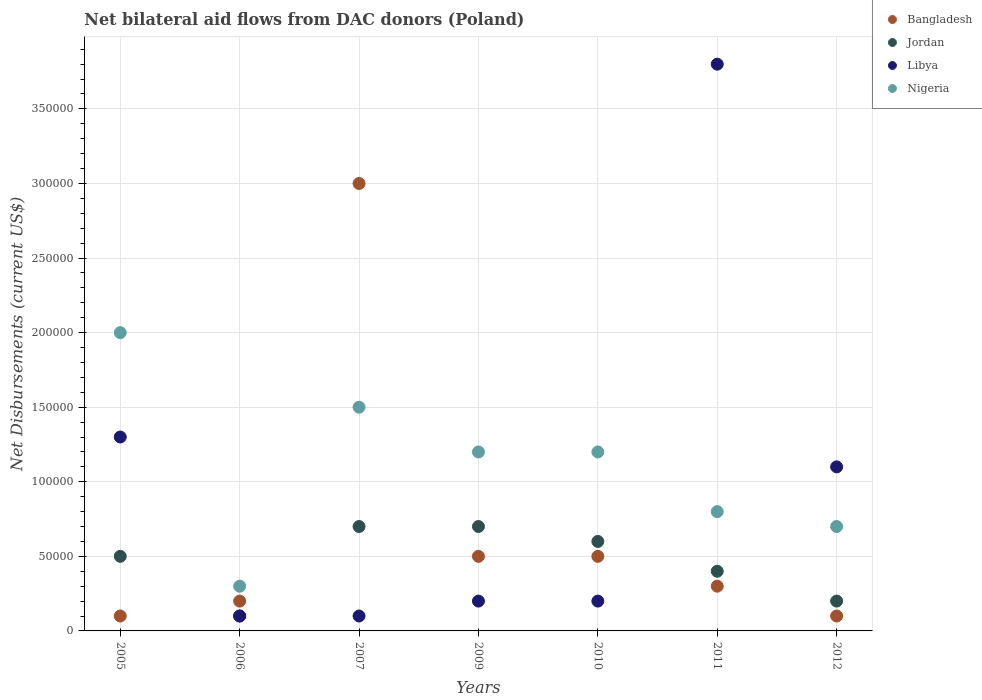How many different coloured dotlines are there?
Provide a short and direct response. 4. What is the net bilateral aid flows in Jordan in 2009?
Provide a succinct answer. 7.00e+04. Across all years, what is the maximum net bilateral aid flows in Bangladesh?
Your answer should be compact. 3.00e+05. Across all years, what is the minimum net bilateral aid flows in Bangladesh?
Make the answer very short. 10000. What is the total net bilateral aid flows in Jordan in the graph?
Ensure brevity in your answer.  3.20e+05. What is the difference between the net bilateral aid flows in Nigeria in 2007 and that in 2010?
Offer a terse response. 3.00e+04. What is the difference between the net bilateral aid flows in Nigeria in 2007 and the net bilateral aid flows in Jordan in 2010?
Ensure brevity in your answer.  9.00e+04. What is the average net bilateral aid flows in Jordan per year?
Give a very brief answer. 4.57e+04. In the year 2009, what is the difference between the net bilateral aid flows in Libya and net bilateral aid flows in Jordan?
Provide a succinct answer. -5.00e+04. Is the net bilateral aid flows in Nigeria in 2007 less than that in 2012?
Give a very brief answer. No. What is the difference between the highest and the second highest net bilateral aid flows in Nigeria?
Offer a terse response. 5.00e+04. What is the difference between the highest and the lowest net bilateral aid flows in Nigeria?
Give a very brief answer. 1.70e+05. In how many years, is the net bilateral aid flows in Jordan greater than the average net bilateral aid flows in Jordan taken over all years?
Keep it short and to the point. 4. Is the net bilateral aid flows in Jordan strictly less than the net bilateral aid flows in Libya over the years?
Make the answer very short. No. How many dotlines are there?
Offer a very short reply. 4. How many years are there in the graph?
Your answer should be compact. 7. What is the difference between two consecutive major ticks on the Y-axis?
Offer a very short reply. 5.00e+04. Does the graph contain any zero values?
Offer a terse response. No. Where does the legend appear in the graph?
Your answer should be compact. Top right. How many legend labels are there?
Keep it short and to the point. 4. What is the title of the graph?
Provide a short and direct response. Net bilateral aid flows from DAC donors (Poland). Does "Spain" appear as one of the legend labels in the graph?
Give a very brief answer. No. What is the label or title of the Y-axis?
Make the answer very short. Net Disbursements (current US$). What is the Net Disbursements (current US$) in Bangladesh in 2005?
Offer a terse response. 10000. What is the Net Disbursements (current US$) in Jordan in 2005?
Keep it short and to the point. 5.00e+04. What is the Net Disbursements (current US$) of Bangladesh in 2006?
Your response must be concise. 2.00e+04. What is the Net Disbursements (current US$) of Jordan in 2006?
Provide a short and direct response. 10000. What is the Net Disbursements (current US$) in Nigeria in 2006?
Keep it short and to the point. 3.00e+04. What is the Net Disbursements (current US$) in Bangladesh in 2007?
Offer a terse response. 3.00e+05. What is the Net Disbursements (current US$) in Jordan in 2007?
Your answer should be compact. 7.00e+04. What is the Net Disbursements (current US$) of Libya in 2007?
Make the answer very short. 10000. What is the Net Disbursements (current US$) of Nigeria in 2007?
Offer a very short reply. 1.50e+05. What is the Net Disbursements (current US$) in Bangladesh in 2009?
Keep it short and to the point. 5.00e+04. What is the Net Disbursements (current US$) in Libya in 2009?
Provide a short and direct response. 2.00e+04. What is the Net Disbursements (current US$) in Bangladesh in 2010?
Provide a succinct answer. 5.00e+04. What is the Net Disbursements (current US$) in Jordan in 2010?
Ensure brevity in your answer.  6.00e+04. What is the Net Disbursements (current US$) in Nigeria in 2010?
Provide a short and direct response. 1.20e+05. What is the Net Disbursements (current US$) in Bangladesh in 2011?
Provide a short and direct response. 3.00e+04. What is the Net Disbursements (current US$) of Libya in 2011?
Make the answer very short. 3.80e+05. What is the Net Disbursements (current US$) of Nigeria in 2011?
Provide a succinct answer. 8.00e+04. What is the Net Disbursements (current US$) in Bangladesh in 2012?
Your answer should be very brief. 10000. What is the Net Disbursements (current US$) in Nigeria in 2012?
Your answer should be very brief. 7.00e+04. Across all years, what is the maximum Net Disbursements (current US$) in Bangladesh?
Give a very brief answer. 3.00e+05. Across all years, what is the maximum Net Disbursements (current US$) of Libya?
Your answer should be compact. 3.80e+05. Across all years, what is the maximum Net Disbursements (current US$) of Nigeria?
Your answer should be very brief. 2.00e+05. Across all years, what is the minimum Net Disbursements (current US$) in Bangladesh?
Provide a succinct answer. 10000. Across all years, what is the minimum Net Disbursements (current US$) in Jordan?
Your answer should be very brief. 10000. Across all years, what is the minimum Net Disbursements (current US$) of Libya?
Ensure brevity in your answer.  10000. Across all years, what is the minimum Net Disbursements (current US$) in Nigeria?
Provide a succinct answer. 3.00e+04. What is the total Net Disbursements (current US$) in Bangladesh in the graph?
Provide a succinct answer. 4.70e+05. What is the total Net Disbursements (current US$) of Jordan in the graph?
Your response must be concise. 3.20e+05. What is the total Net Disbursements (current US$) in Libya in the graph?
Your answer should be compact. 6.80e+05. What is the total Net Disbursements (current US$) of Nigeria in the graph?
Provide a short and direct response. 7.70e+05. What is the difference between the Net Disbursements (current US$) in Bangladesh in 2005 and that in 2006?
Offer a very short reply. -10000. What is the difference between the Net Disbursements (current US$) in Jordan in 2005 and that in 2006?
Make the answer very short. 4.00e+04. What is the difference between the Net Disbursements (current US$) in Jordan in 2005 and that in 2007?
Provide a succinct answer. -2.00e+04. What is the difference between the Net Disbursements (current US$) in Jordan in 2005 and that in 2009?
Your response must be concise. -2.00e+04. What is the difference between the Net Disbursements (current US$) of Libya in 2005 and that in 2009?
Your answer should be compact. 1.10e+05. What is the difference between the Net Disbursements (current US$) of Nigeria in 2005 and that in 2009?
Offer a very short reply. 8.00e+04. What is the difference between the Net Disbursements (current US$) in Jordan in 2005 and that in 2010?
Keep it short and to the point. -10000. What is the difference between the Net Disbursements (current US$) in Libya in 2005 and that in 2010?
Provide a short and direct response. 1.10e+05. What is the difference between the Net Disbursements (current US$) in Nigeria in 2005 and that in 2010?
Your answer should be compact. 8.00e+04. What is the difference between the Net Disbursements (current US$) of Jordan in 2005 and that in 2011?
Your answer should be very brief. 10000. What is the difference between the Net Disbursements (current US$) in Libya in 2005 and that in 2011?
Your answer should be very brief. -2.50e+05. What is the difference between the Net Disbursements (current US$) in Bangladesh in 2005 and that in 2012?
Provide a succinct answer. 0. What is the difference between the Net Disbursements (current US$) of Libya in 2005 and that in 2012?
Offer a very short reply. 2.00e+04. What is the difference between the Net Disbursements (current US$) in Nigeria in 2005 and that in 2012?
Offer a very short reply. 1.30e+05. What is the difference between the Net Disbursements (current US$) in Bangladesh in 2006 and that in 2007?
Make the answer very short. -2.80e+05. What is the difference between the Net Disbursements (current US$) in Nigeria in 2006 and that in 2007?
Offer a terse response. -1.20e+05. What is the difference between the Net Disbursements (current US$) in Bangladesh in 2006 and that in 2009?
Offer a terse response. -3.00e+04. What is the difference between the Net Disbursements (current US$) in Libya in 2006 and that in 2009?
Offer a terse response. -10000. What is the difference between the Net Disbursements (current US$) of Bangladesh in 2006 and that in 2010?
Provide a short and direct response. -3.00e+04. What is the difference between the Net Disbursements (current US$) in Jordan in 2006 and that in 2010?
Ensure brevity in your answer.  -5.00e+04. What is the difference between the Net Disbursements (current US$) in Libya in 2006 and that in 2010?
Keep it short and to the point. -10000. What is the difference between the Net Disbursements (current US$) in Nigeria in 2006 and that in 2010?
Make the answer very short. -9.00e+04. What is the difference between the Net Disbursements (current US$) of Bangladesh in 2006 and that in 2011?
Your response must be concise. -10000. What is the difference between the Net Disbursements (current US$) in Jordan in 2006 and that in 2011?
Offer a terse response. -3.00e+04. What is the difference between the Net Disbursements (current US$) in Libya in 2006 and that in 2011?
Your response must be concise. -3.70e+05. What is the difference between the Net Disbursements (current US$) in Bangladesh in 2006 and that in 2012?
Make the answer very short. 10000. What is the difference between the Net Disbursements (current US$) of Jordan in 2006 and that in 2012?
Keep it short and to the point. -10000. What is the difference between the Net Disbursements (current US$) of Nigeria in 2006 and that in 2012?
Offer a terse response. -4.00e+04. What is the difference between the Net Disbursements (current US$) of Jordan in 2007 and that in 2009?
Give a very brief answer. 0. What is the difference between the Net Disbursements (current US$) of Libya in 2007 and that in 2009?
Give a very brief answer. -10000. What is the difference between the Net Disbursements (current US$) in Nigeria in 2007 and that in 2009?
Provide a succinct answer. 3.00e+04. What is the difference between the Net Disbursements (current US$) in Bangladesh in 2007 and that in 2010?
Provide a short and direct response. 2.50e+05. What is the difference between the Net Disbursements (current US$) in Libya in 2007 and that in 2010?
Keep it short and to the point. -10000. What is the difference between the Net Disbursements (current US$) in Jordan in 2007 and that in 2011?
Ensure brevity in your answer.  3.00e+04. What is the difference between the Net Disbursements (current US$) in Libya in 2007 and that in 2011?
Provide a short and direct response. -3.70e+05. What is the difference between the Net Disbursements (current US$) of Jordan in 2007 and that in 2012?
Your answer should be compact. 5.00e+04. What is the difference between the Net Disbursements (current US$) of Libya in 2007 and that in 2012?
Provide a short and direct response. -1.00e+05. What is the difference between the Net Disbursements (current US$) of Nigeria in 2007 and that in 2012?
Provide a short and direct response. 8.00e+04. What is the difference between the Net Disbursements (current US$) in Bangladesh in 2009 and that in 2010?
Offer a terse response. 0. What is the difference between the Net Disbursements (current US$) in Libya in 2009 and that in 2011?
Your response must be concise. -3.60e+05. What is the difference between the Net Disbursements (current US$) of Jordan in 2009 and that in 2012?
Offer a very short reply. 5.00e+04. What is the difference between the Net Disbursements (current US$) of Libya in 2009 and that in 2012?
Keep it short and to the point. -9.00e+04. What is the difference between the Net Disbursements (current US$) of Nigeria in 2009 and that in 2012?
Your answer should be very brief. 5.00e+04. What is the difference between the Net Disbursements (current US$) of Jordan in 2010 and that in 2011?
Your answer should be compact. 2.00e+04. What is the difference between the Net Disbursements (current US$) of Libya in 2010 and that in 2011?
Offer a terse response. -3.60e+05. What is the difference between the Net Disbursements (current US$) in Libya in 2010 and that in 2012?
Give a very brief answer. -9.00e+04. What is the difference between the Net Disbursements (current US$) in Nigeria in 2010 and that in 2012?
Ensure brevity in your answer.  5.00e+04. What is the difference between the Net Disbursements (current US$) of Bangladesh in 2011 and that in 2012?
Make the answer very short. 2.00e+04. What is the difference between the Net Disbursements (current US$) in Jordan in 2011 and that in 2012?
Keep it short and to the point. 2.00e+04. What is the difference between the Net Disbursements (current US$) in Libya in 2011 and that in 2012?
Your answer should be very brief. 2.70e+05. What is the difference between the Net Disbursements (current US$) in Bangladesh in 2005 and the Net Disbursements (current US$) in Jordan in 2006?
Keep it short and to the point. 0. What is the difference between the Net Disbursements (current US$) of Libya in 2005 and the Net Disbursements (current US$) of Nigeria in 2006?
Your answer should be very brief. 1.00e+05. What is the difference between the Net Disbursements (current US$) of Bangladesh in 2005 and the Net Disbursements (current US$) of Nigeria in 2007?
Offer a very short reply. -1.40e+05. What is the difference between the Net Disbursements (current US$) in Jordan in 2005 and the Net Disbursements (current US$) in Libya in 2007?
Offer a terse response. 4.00e+04. What is the difference between the Net Disbursements (current US$) in Jordan in 2005 and the Net Disbursements (current US$) in Nigeria in 2007?
Make the answer very short. -1.00e+05. What is the difference between the Net Disbursements (current US$) in Bangladesh in 2005 and the Net Disbursements (current US$) in Jordan in 2009?
Your answer should be very brief. -6.00e+04. What is the difference between the Net Disbursements (current US$) of Bangladesh in 2005 and the Net Disbursements (current US$) of Libya in 2009?
Offer a terse response. -10000. What is the difference between the Net Disbursements (current US$) in Jordan in 2005 and the Net Disbursements (current US$) in Nigeria in 2009?
Provide a short and direct response. -7.00e+04. What is the difference between the Net Disbursements (current US$) in Libya in 2005 and the Net Disbursements (current US$) in Nigeria in 2009?
Your response must be concise. 10000. What is the difference between the Net Disbursements (current US$) in Bangladesh in 2005 and the Net Disbursements (current US$) in Jordan in 2010?
Offer a terse response. -5.00e+04. What is the difference between the Net Disbursements (current US$) in Libya in 2005 and the Net Disbursements (current US$) in Nigeria in 2010?
Offer a terse response. 10000. What is the difference between the Net Disbursements (current US$) of Bangladesh in 2005 and the Net Disbursements (current US$) of Libya in 2011?
Your answer should be compact. -3.70e+05. What is the difference between the Net Disbursements (current US$) in Jordan in 2005 and the Net Disbursements (current US$) in Libya in 2011?
Ensure brevity in your answer.  -3.30e+05. What is the difference between the Net Disbursements (current US$) in Jordan in 2005 and the Net Disbursements (current US$) in Nigeria in 2011?
Your response must be concise. -3.00e+04. What is the difference between the Net Disbursements (current US$) in Libya in 2005 and the Net Disbursements (current US$) in Nigeria in 2011?
Your answer should be very brief. 5.00e+04. What is the difference between the Net Disbursements (current US$) of Jordan in 2005 and the Net Disbursements (current US$) of Nigeria in 2012?
Your answer should be compact. -2.00e+04. What is the difference between the Net Disbursements (current US$) in Libya in 2005 and the Net Disbursements (current US$) in Nigeria in 2012?
Provide a succinct answer. 6.00e+04. What is the difference between the Net Disbursements (current US$) in Bangladesh in 2006 and the Net Disbursements (current US$) in Jordan in 2007?
Keep it short and to the point. -5.00e+04. What is the difference between the Net Disbursements (current US$) of Bangladesh in 2006 and the Net Disbursements (current US$) of Libya in 2007?
Offer a terse response. 10000. What is the difference between the Net Disbursements (current US$) in Jordan in 2006 and the Net Disbursements (current US$) in Libya in 2007?
Your answer should be compact. 0. What is the difference between the Net Disbursements (current US$) in Jordan in 2006 and the Net Disbursements (current US$) in Nigeria in 2007?
Offer a terse response. -1.40e+05. What is the difference between the Net Disbursements (current US$) of Bangladesh in 2006 and the Net Disbursements (current US$) of Jordan in 2009?
Make the answer very short. -5.00e+04. What is the difference between the Net Disbursements (current US$) of Jordan in 2006 and the Net Disbursements (current US$) of Libya in 2009?
Give a very brief answer. -10000. What is the difference between the Net Disbursements (current US$) of Jordan in 2006 and the Net Disbursements (current US$) of Nigeria in 2009?
Offer a terse response. -1.10e+05. What is the difference between the Net Disbursements (current US$) in Libya in 2006 and the Net Disbursements (current US$) in Nigeria in 2009?
Offer a very short reply. -1.10e+05. What is the difference between the Net Disbursements (current US$) of Bangladesh in 2006 and the Net Disbursements (current US$) of Libya in 2010?
Keep it short and to the point. 0. What is the difference between the Net Disbursements (current US$) in Bangladesh in 2006 and the Net Disbursements (current US$) in Nigeria in 2010?
Provide a succinct answer. -1.00e+05. What is the difference between the Net Disbursements (current US$) of Jordan in 2006 and the Net Disbursements (current US$) of Libya in 2010?
Keep it short and to the point. -10000. What is the difference between the Net Disbursements (current US$) in Jordan in 2006 and the Net Disbursements (current US$) in Nigeria in 2010?
Offer a very short reply. -1.10e+05. What is the difference between the Net Disbursements (current US$) in Libya in 2006 and the Net Disbursements (current US$) in Nigeria in 2010?
Offer a terse response. -1.10e+05. What is the difference between the Net Disbursements (current US$) in Bangladesh in 2006 and the Net Disbursements (current US$) in Jordan in 2011?
Keep it short and to the point. -2.00e+04. What is the difference between the Net Disbursements (current US$) of Bangladesh in 2006 and the Net Disbursements (current US$) of Libya in 2011?
Offer a very short reply. -3.60e+05. What is the difference between the Net Disbursements (current US$) in Bangladesh in 2006 and the Net Disbursements (current US$) in Nigeria in 2011?
Your answer should be very brief. -6.00e+04. What is the difference between the Net Disbursements (current US$) in Jordan in 2006 and the Net Disbursements (current US$) in Libya in 2011?
Give a very brief answer. -3.70e+05. What is the difference between the Net Disbursements (current US$) in Jordan in 2006 and the Net Disbursements (current US$) in Nigeria in 2011?
Your response must be concise. -7.00e+04. What is the difference between the Net Disbursements (current US$) of Libya in 2006 and the Net Disbursements (current US$) of Nigeria in 2011?
Your answer should be compact. -7.00e+04. What is the difference between the Net Disbursements (current US$) of Bangladesh in 2006 and the Net Disbursements (current US$) of Jordan in 2012?
Provide a short and direct response. 0. What is the difference between the Net Disbursements (current US$) of Jordan in 2006 and the Net Disbursements (current US$) of Libya in 2012?
Your answer should be very brief. -1.00e+05. What is the difference between the Net Disbursements (current US$) of Bangladesh in 2007 and the Net Disbursements (current US$) of Libya in 2009?
Offer a very short reply. 2.80e+05. What is the difference between the Net Disbursements (current US$) in Jordan in 2007 and the Net Disbursements (current US$) in Nigeria in 2009?
Make the answer very short. -5.00e+04. What is the difference between the Net Disbursements (current US$) of Libya in 2007 and the Net Disbursements (current US$) of Nigeria in 2009?
Make the answer very short. -1.10e+05. What is the difference between the Net Disbursements (current US$) of Jordan in 2007 and the Net Disbursements (current US$) of Libya in 2010?
Make the answer very short. 5.00e+04. What is the difference between the Net Disbursements (current US$) in Libya in 2007 and the Net Disbursements (current US$) in Nigeria in 2010?
Offer a very short reply. -1.10e+05. What is the difference between the Net Disbursements (current US$) in Bangladesh in 2007 and the Net Disbursements (current US$) in Jordan in 2011?
Make the answer very short. 2.60e+05. What is the difference between the Net Disbursements (current US$) in Bangladesh in 2007 and the Net Disbursements (current US$) in Nigeria in 2011?
Make the answer very short. 2.20e+05. What is the difference between the Net Disbursements (current US$) of Jordan in 2007 and the Net Disbursements (current US$) of Libya in 2011?
Ensure brevity in your answer.  -3.10e+05. What is the difference between the Net Disbursements (current US$) in Bangladesh in 2007 and the Net Disbursements (current US$) in Jordan in 2012?
Your answer should be very brief. 2.80e+05. What is the difference between the Net Disbursements (current US$) of Jordan in 2007 and the Net Disbursements (current US$) of Nigeria in 2012?
Keep it short and to the point. 0. What is the difference between the Net Disbursements (current US$) of Libya in 2007 and the Net Disbursements (current US$) of Nigeria in 2012?
Your answer should be compact. -6.00e+04. What is the difference between the Net Disbursements (current US$) of Bangladesh in 2009 and the Net Disbursements (current US$) of Libya in 2010?
Give a very brief answer. 3.00e+04. What is the difference between the Net Disbursements (current US$) of Bangladesh in 2009 and the Net Disbursements (current US$) of Nigeria in 2010?
Offer a terse response. -7.00e+04. What is the difference between the Net Disbursements (current US$) in Libya in 2009 and the Net Disbursements (current US$) in Nigeria in 2010?
Your response must be concise. -1.00e+05. What is the difference between the Net Disbursements (current US$) in Bangladesh in 2009 and the Net Disbursements (current US$) in Libya in 2011?
Your answer should be compact. -3.30e+05. What is the difference between the Net Disbursements (current US$) of Bangladesh in 2009 and the Net Disbursements (current US$) of Nigeria in 2011?
Your answer should be compact. -3.00e+04. What is the difference between the Net Disbursements (current US$) of Jordan in 2009 and the Net Disbursements (current US$) of Libya in 2011?
Provide a short and direct response. -3.10e+05. What is the difference between the Net Disbursements (current US$) of Jordan in 2009 and the Net Disbursements (current US$) of Nigeria in 2011?
Make the answer very short. -10000. What is the difference between the Net Disbursements (current US$) in Bangladesh in 2009 and the Net Disbursements (current US$) in Libya in 2012?
Provide a short and direct response. -6.00e+04. What is the difference between the Net Disbursements (current US$) in Jordan in 2009 and the Net Disbursements (current US$) in Libya in 2012?
Your answer should be compact. -4.00e+04. What is the difference between the Net Disbursements (current US$) in Bangladesh in 2010 and the Net Disbursements (current US$) in Jordan in 2011?
Give a very brief answer. 10000. What is the difference between the Net Disbursements (current US$) of Bangladesh in 2010 and the Net Disbursements (current US$) of Libya in 2011?
Your answer should be compact. -3.30e+05. What is the difference between the Net Disbursements (current US$) of Bangladesh in 2010 and the Net Disbursements (current US$) of Nigeria in 2011?
Your answer should be compact. -3.00e+04. What is the difference between the Net Disbursements (current US$) in Jordan in 2010 and the Net Disbursements (current US$) in Libya in 2011?
Provide a succinct answer. -3.20e+05. What is the difference between the Net Disbursements (current US$) of Libya in 2010 and the Net Disbursements (current US$) of Nigeria in 2011?
Make the answer very short. -6.00e+04. What is the difference between the Net Disbursements (current US$) of Bangladesh in 2010 and the Net Disbursements (current US$) of Nigeria in 2012?
Your response must be concise. -2.00e+04. What is the difference between the Net Disbursements (current US$) in Bangladesh in 2011 and the Net Disbursements (current US$) in Libya in 2012?
Offer a very short reply. -8.00e+04. What is the difference between the Net Disbursements (current US$) of Bangladesh in 2011 and the Net Disbursements (current US$) of Nigeria in 2012?
Provide a succinct answer. -4.00e+04. What is the difference between the Net Disbursements (current US$) of Jordan in 2011 and the Net Disbursements (current US$) of Libya in 2012?
Provide a short and direct response. -7.00e+04. What is the difference between the Net Disbursements (current US$) in Jordan in 2011 and the Net Disbursements (current US$) in Nigeria in 2012?
Provide a short and direct response. -3.00e+04. What is the average Net Disbursements (current US$) of Bangladesh per year?
Offer a very short reply. 6.71e+04. What is the average Net Disbursements (current US$) in Jordan per year?
Your response must be concise. 4.57e+04. What is the average Net Disbursements (current US$) in Libya per year?
Keep it short and to the point. 9.71e+04. In the year 2005, what is the difference between the Net Disbursements (current US$) of Bangladesh and Net Disbursements (current US$) of Jordan?
Provide a short and direct response. -4.00e+04. In the year 2005, what is the difference between the Net Disbursements (current US$) in Bangladesh and Net Disbursements (current US$) in Libya?
Offer a terse response. -1.20e+05. In the year 2005, what is the difference between the Net Disbursements (current US$) of Jordan and Net Disbursements (current US$) of Libya?
Keep it short and to the point. -8.00e+04. In the year 2006, what is the difference between the Net Disbursements (current US$) of Bangladesh and Net Disbursements (current US$) of Jordan?
Offer a very short reply. 10000. In the year 2006, what is the difference between the Net Disbursements (current US$) of Bangladesh and Net Disbursements (current US$) of Libya?
Your response must be concise. 10000. In the year 2006, what is the difference between the Net Disbursements (current US$) in Jordan and Net Disbursements (current US$) in Libya?
Provide a short and direct response. 0. In the year 2007, what is the difference between the Net Disbursements (current US$) of Bangladesh and Net Disbursements (current US$) of Nigeria?
Your answer should be compact. 1.50e+05. In the year 2007, what is the difference between the Net Disbursements (current US$) of Libya and Net Disbursements (current US$) of Nigeria?
Provide a short and direct response. -1.40e+05. In the year 2009, what is the difference between the Net Disbursements (current US$) in Bangladesh and Net Disbursements (current US$) in Jordan?
Give a very brief answer. -2.00e+04. In the year 2009, what is the difference between the Net Disbursements (current US$) of Bangladesh and Net Disbursements (current US$) of Libya?
Your answer should be compact. 3.00e+04. In the year 2009, what is the difference between the Net Disbursements (current US$) in Bangladesh and Net Disbursements (current US$) in Nigeria?
Your answer should be compact. -7.00e+04. In the year 2009, what is the difference between the Net Disbursements (current US$) in Jordan and Net Disbursements (current US$) in Libya?
Your response must be concise. 5.00e+04. In the year 2009, what is the difference between the Net Disbursements (current US$) of Libya and Net Disbursements (current US$) of Nigeria?
Make the answer very short. -1.00e+05. In the year 2010, what is the difference between the Net Disbursements (current US$) of Bangladesh and Net Disbursements (current US$) of Libya?
Provide a short and direct response. 3.00e+04. In the year 2010, what is the difference between the Net Disbursements (current US$) of Bangladesh and Net Disbursements (current US$) of Nigeria?
Your answer should be very brief. -7.00e+04. In the year 2010, what is the difference between the Net Disbursements (current US$) of Jordan and Net Disbursements (current US$) of Libya?
Keep it short and to the point. 4.00e+04. In the year 2010, what is the difference between the Net Disbursements (current US$) of Jordan and Net Disbursements (current US$) of Nigeria?
Your response must be concise. -6.00e+04. In the year 2010, what is the difference between the Net Disbursements (current US$) in Libya and Net Disbursements (current US$) in Nigeria?
Your answer should be very brief. -1.00e+05. In the year 2011, what is the difference between the Net Disbursements (current US$) of Bangladesh and Net Disbursements (current US$) of Libya?
Offer a very short reply. -3.50e+05. In the year 2011, what is the difference between the Net Disbursements (current US$) of Libya and Net Disbursements (current US$) of Nigeria?
Your answer should be compact. 3.00e+05. In the year 2012, what is the difference between the Net Disbursements (current US$) of Jordan and Net Disbursements (current US$) of Libya?
Provide a succinct answer. -9.00e+04. In the year 2012, what is the difference between the Net Disbursements (current US$) of Jordan and Net Disbursements (current US$) of Nigeria?
Make the answer very short. -5.00e+04. What is the ratio of the Net Disbursements (current US$) in Jordan in 2005 to that in 2006?
Provide a short and direct response. 5. What is the ratio of the Net Disbursements (current US$) of Libya in 2005 to that in 2006?
Give a very brief answer. 13. What is the ratio of the Net Disbursements (current US$) of Nigeria in 2005 to that in 2006?
Your answer should be compact. 6.67. What is the ratio of the Net Disbursements (current US$) in Bangladesh in 2005 to that in 2007?
Give a very brief answer. 0.03. What is the ratio of the Net Disbursements (current US$) in Libya in 2005 to that in 2007?
Your response must be concise. 13. What is the ratio of the Net Disbursements (current US$) in Jordan in 2005 to that in 2009?
Your answer should be compact. 0.71. What is the ratio of the Net Disbursements (current US$) in Libya in 2005 to that in 2009?
Offer a very short reply. 6.5. What is the ratio of the Net Disbursements (current US$) in Nigeria in 2005 to that in 2009?
Give a very brief answer. 1.67. What is the ratio of the Net Disbursements (current US$) in Nigeria in 2005 to that in 2010?
Offer a very short reply. 1.67. What is the ratio of the Net Disbursements (current US$) of Jordan in 2005 to that in 2011?
Keep it short and to the point. 1.25. What is the ratio of the Net Disbursements (current US$) in Libya in 2005 to that in 2011?
Offer a terse response. 0.34. What is the ratio of the Net Disbursements (current US$) of Nigeria in 2005 to that in 2011?
Your answer should be compact. 2.5. What is the ratio of the Net Disbursements (current US$) in Libya in 2005 to that in 2012?
Keep it short and to the point. 1.18. What is the ratio of the Net Disbursements (current US$) of Nigeria in 2005 to that in 2012?
Your answer should be very brief. 2.86. What is the ratio of the Net Disbursements (current US$) of Bangladesh in 2006 to that in 2007?
Ensure brevity in your answer.  0.07. What is the ratio of the Net Disbursements (current US$) in Jordan in 2006 to that in 2007?
Offer a terse response. 0.14. What is the ratio of the Net Disbursements (current US$) of Nigeria in 2006 to that in 2007?
Your response must be concise. 0.2. What is the ratio of the Net Disbursements (current US$) in Jordan in 2006 to that in 2009?
Give a very brief answer. 0.14. What is the ratio of the Net Disbursements (current US$) in Libya in 2006 to that in 2009?
Give a very brief answer. 0.5. What is the ratio of the Net Disbursements (current US$) in Nigeria in 2006 to that in 2009?
Offer a terse response. 0.25. What is the ratio of the Net Disbursements (current US$) in Jordan in 2006 to that in 2010?
Offer a very short reply. 0.17. What is the ratio of the Net Disbursements (current US$) of Libya in 2006 to that in 2010?
Offer a very short reply. 0.5. What is the ratio of the Net Disbursements (current US$) of Nigeria in 2006 to that in 2010?
Offer a terse response. 0.25. What is the ratio of the Net Disbursements (current US$) of Jordan in 2006 to that in 2011?
Your answer should be very brief. 0.25. What is the ratio of the Net Disbursements (current US$) in Libya in 2006 to that in 2011?
Make the answer very short. 0.03. What is the ratio of the Net Disbursements (current US$) of Bangladesh in 2006 to that in 2012?
Give a very brief answer. 2. What is the ratio of the Net Disbursements (current US$) in Jordan in 2006 to that in 2012?
Keep it short and to the point. 0.5. What is the ratio of the Net Disbursements (current US$) in Libya in 2006 to that in 2012?
Provide a succinct answer. 0.09. What is the ratio of the Net Disbursements (current US$) in Nigeria in 2006 to that in 2012?
Provide a short and direct response. 0.43. What is the ratio of the Net Disbursements (current US$) in Nigeria in 2007 to that in 2009?
Keep it short and to the point. 1.25. What is the ratio of the Net Disbursements (current US$) in Jordan in 2007 to that in 2010?
Make the answer very short. 1.17. What is the ratio of the Net Disbursements (current US$) in Libya in 2007 to that in 2010?
Keep it short and to the point. 0.5. What is the ratio of the Net Disbursements (current US$) in Nigeria in 2007 to that in 2010?
Keep it short and to the point. 1.25. What is the ratio of the Net Disbursements (current US$) of Bangladesh in 2007 to that in 2011?
Offer a very short reply. 10. What is the ratio of the Net Disbursements (current US$) in Jordan in 2007 to that in 2011?
Your response must be concise. 1.75. What is the ratio of the Net Disbursements (current US$) in Libya in 2007 to that in 2011?
Keep it short and to the point. 0.03. What is the ratio of the Net Disbursements (current US$) in Nigeria in 2007 to that in 2011?
Your response must be concise. 1.88. What is the ratio of the Net Disbursements (current US$) in Jordan in 2007 to that in 2012?
Provide a short and direct response. 3.5. What is the ratio of the Net Disbursements (current US$) of Libya in 2007 to that in 2012?
Give a very brief answer. 0.09. What is the ratio of the Net Disbursements (current US$) in Nigeria in 2007 to that in 2012?
Provide a succinct answer. 2.14. What is the ratio of the Net Disbursements (current US$) of Libya in 2009 to that in 2010?
Ensure brevity in your answer.  1. What is the ratio of the Net Disbursements (current US$) of Nigeria in 2009 to that in 2010?
Give a very brief answer. 1. What is the ratio of the Net Disbursements (current US$) of Bangladesh in 2009 to that in 2011?
Your answer should be very brief. 1.67. What is the ratio of the Net Disbursements (current US$) in Jordan in 2009 to that in 2011?
Make the answer very short. 1.75. What is the ratio of the Net Disbursements (current US$) in Libya in 2009 to that in 2011?
Ensure brevity in your answer.  0.05. What is the ratio of the Net Disbursements (current US$) in Bangladesh in 2009 to that in 2012?
Provide a succinct answer. 5. What is the ratio of the Net Disbursements (current US$) in Jordan in 2009 to that in 2012?
Offer a very short reply. 3.5. What is the ratio of the Net Disbursements (current US$) of Libya in 2009 to that in 2012?
Give a very brief answer. 0.18. What is the ratio of the Net Disbursements (current US$) of Nigeria in 2009 to that in 2012?
Your response must be concise. 1.71. What is the ratio of the Net Disbursements (current US$) of Jordan in 2010 to that in 2011?
Make the answer very short. 1.5. What is the ratio of the Net Disbursements (current US$) of Libya in 2010 to that in 2011?
Keep it short and to the point. 0.05. What is the ratio of the Net Disbursements (current US$) in Nigeria in 2010 to that in 2011?
Offer a terse response. 1.5. What is the ratio of the Net Disbursements (current US$) in Libya in 2010 to that in 2012?
Your response must be concise. 0.18. What is the ratio of the Net Disbursements (current US$) in Nigeria in 2010 to that in 2012?
Give a very brief answer. 1.71. What is the ratio of the Net Disbursements (current US$) in Jordan in 2011 to that in 2012?
Your answer should be compact. 2. What is the ratio of the Net Disbursements (current US$) of Libya in 2011 to that in 2012?
Provide a short and direct response. 3.45. What is the difference between the highest and the second highest Net Disbursements (current US$) of Jordan?
Provide a short and direct response. 0. 